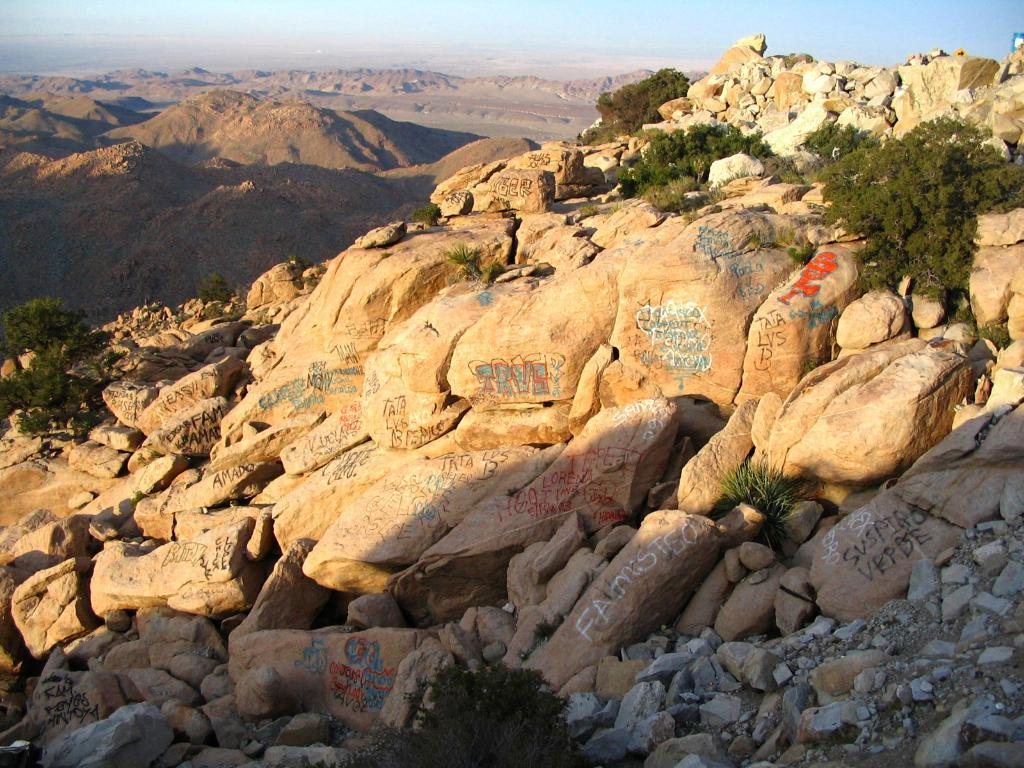What type of natural formation is predominant in the image? There are many mountains in the image. What can be seen at the bottom of the image? There are stones at the bottom of the image. What type of vegetation is on the right side of the image? There are plants on the right side of the image. What is visible at the top of the image? The sky is visible at the top of the image. Where is the hydrant located in the image? There is no hydrant present in the image. What type of skin condition can be seen on the plants in the image? There is no mention of any skin condition on the plants in the image; they appear to be healthy. 